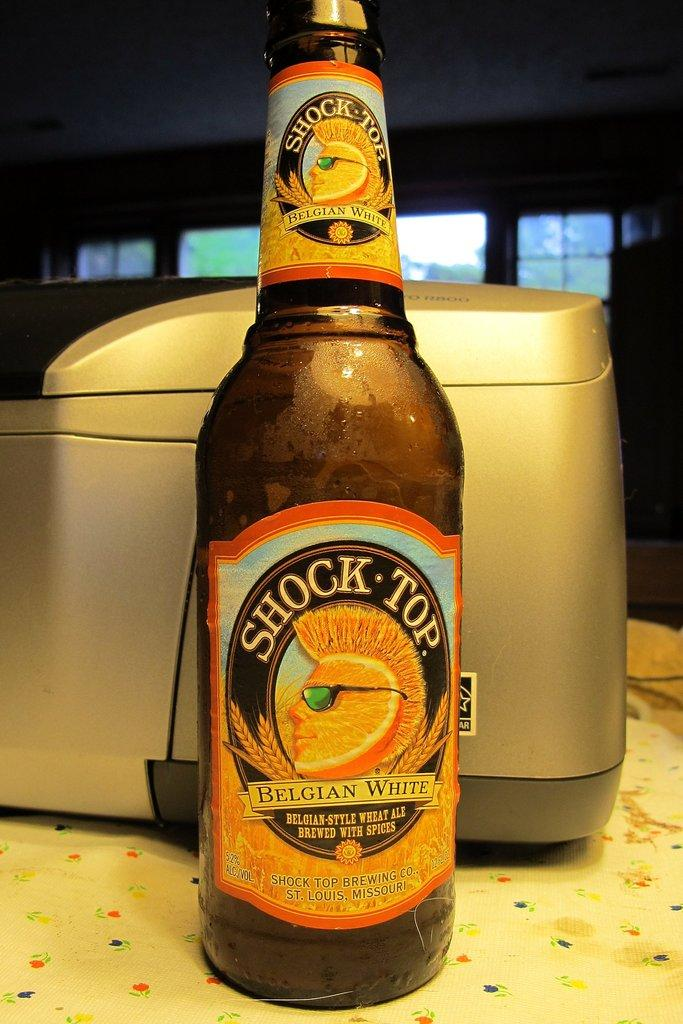<image>
Present a compact description of the photo's key features. A bottle of Shock Top sits unopened on a counter 